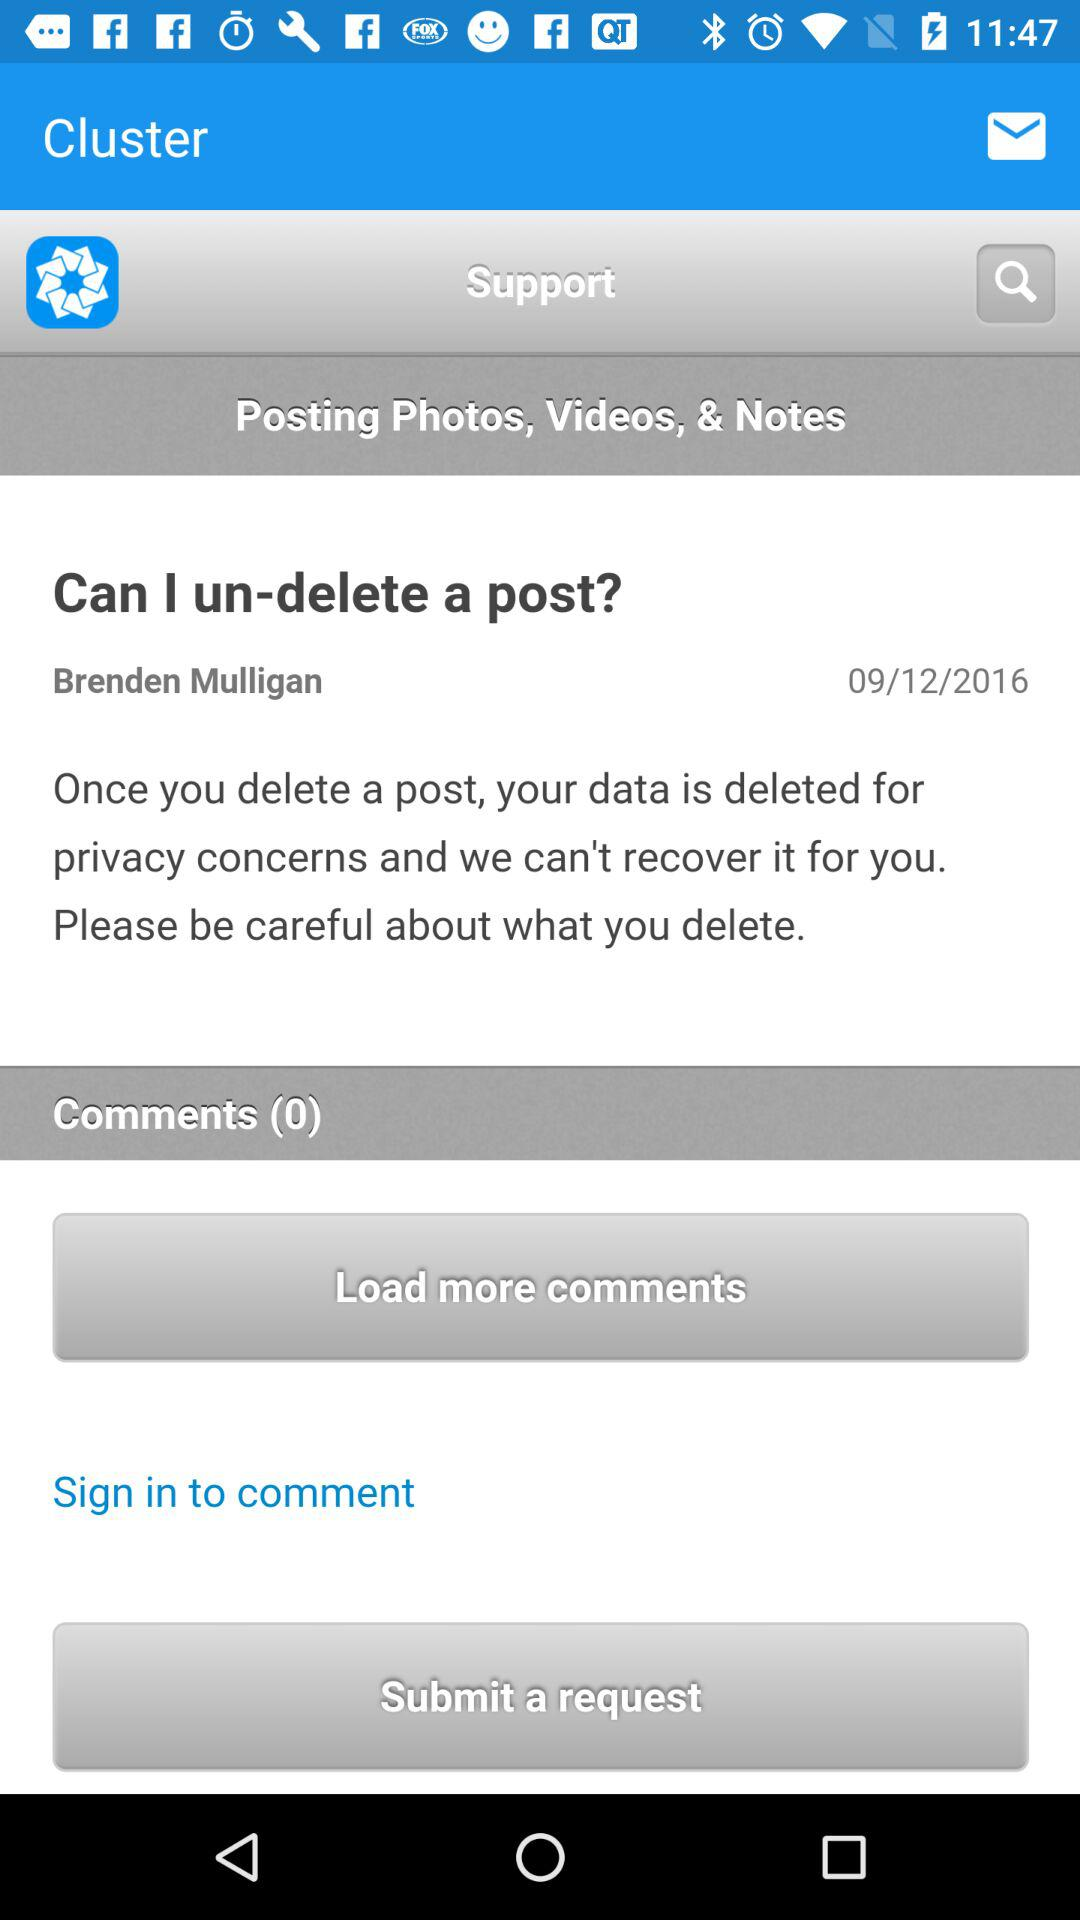What is the date? The date is September 12, 2016. 